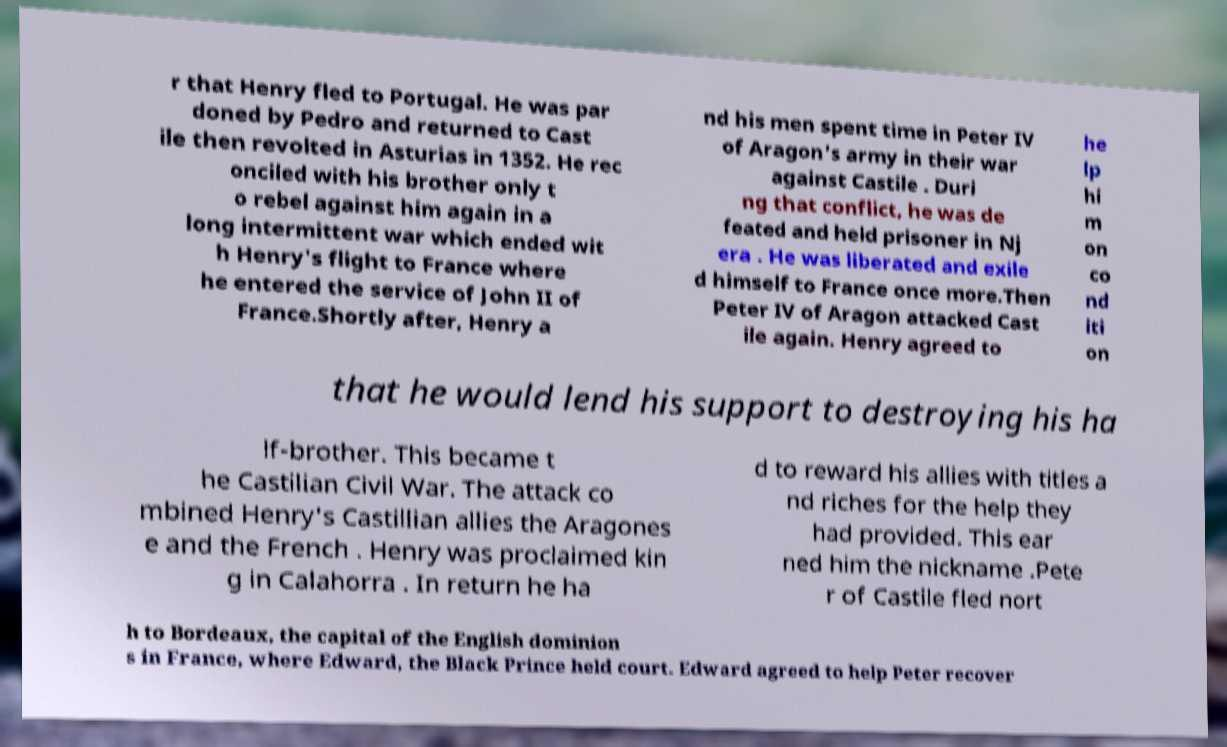Could you assist in decoding the text presented in this image and type it out clearly? r that Henry fled to Portugal. He was par doned by Pedro and returned to Cast ile then revolted in Asturias in 1352. He rec onciled with his brother only t o rebel against him again in a long intermittent war which ended wit h Henry's flight to France where he entered the service of John II of France.Shortly after, Henry a nd his men spent time in Peter IV of Aragon's army in their war against Castile . Duri ng that conflict, he was de feated and held prisoner in Nj era . He was liberated and exile d himself to France once more.Then Peter IV of Aragon attacked Cast ile again. Henry agreed to he lp hi m on co nd iti on that he would lend his support to destroying his ha lf-brother. This became t he Castilian Civil War. The attack co mbined Henry's Castillian allies the Aragones e and the French . Henry was proclaimed kin g in Calahorra . In return he ha d to reward his allies with titles a nd riches for the help they had provided. This ear ned him the nickname .Pete r of Castile fled nort h to Bordeaux, the capital of the English dominion s in France, where Edward, the Black Prince held court. Edward agreed to help Peter recover 